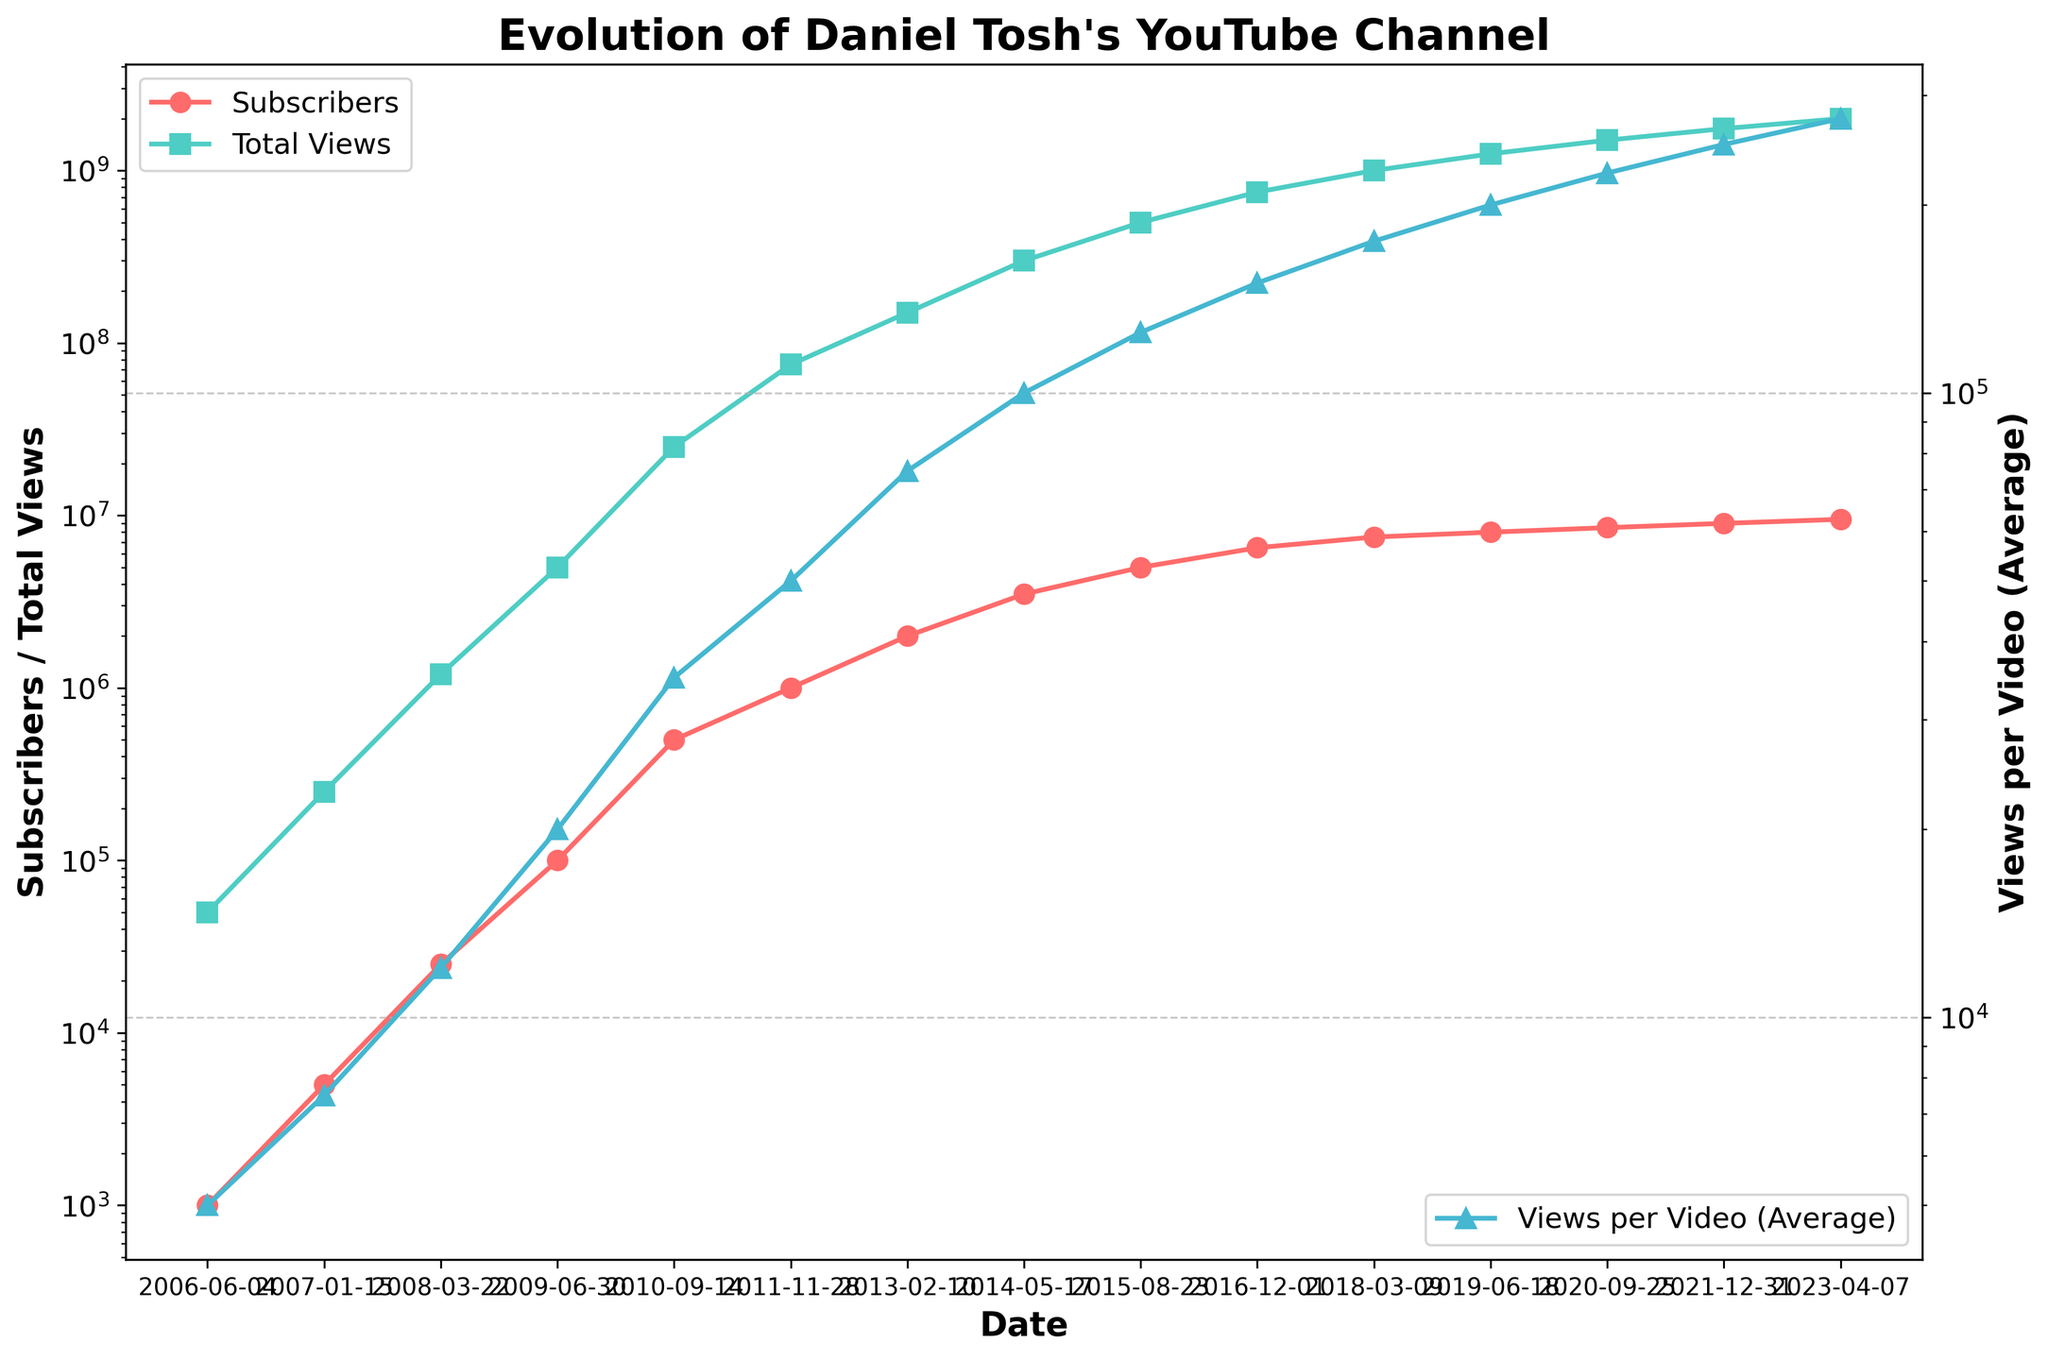What is the total number of subscribers by the end of 2021? Look at the subscriber count for the date "2021-12-31." The value given is 9,000,000.
Answer: 9,000,000 Which year saw the highest increase in subscribers? Find the differences in subscriber count between each consecutive year and compare the increases. The largest increase is between "2010-09-14" (500,000 subscribers) and "2011-11-28" (1,000,000 subscribers), showing an increase of 500,000 within approximately a year.
Answer: 2011 How does the rate of increase in subscribers compare to the rate of increase in total views over the entire period? Calculate the overall increase in subscribers from 1,000 (2006-06-04) to 9,500,000 (2023-04-07) and compare it to the total view increase from 50,000 to 2,000,000,000 in the same period. Subscribers increased by 9,499,000, while views increased by 1,999,950,000. Though both grew substantially, views had a much higher absolute increase.
Answer: Views increased more rapidly What year did views per video (average) surpass 100,000? Observe the "Views per Video (Average)" line and identify the first date after which the value exceeds 100,000. The date is "2014-05-17" with a count of 100,000.
Answer: 2014 In which period (stated in years) did Daniel Tosh's channel have a constant subscriber growth without any drop-off? Analyze the subscriber trend and identify periods where every subsequent data point shows an increase without any dips. From "2006-06-04" (1,000) to "2023-04-07" (9,500,000), the subscriber count has consistently increased.
Answer: 2006 to 2023 What is the difference in total views between 2009 and 2010? Note the values for total views on "2009-06-30" (5,000,000) and "2010-09-14" (25,000,000), then subtract the earlier value from the later one. 25,000,000 - 5,000,000 equals 20,000,000.
Answer: 20,000,000 Which color represents the average views per video on the plot? Identify the color used for the "Views per Video (Average)" line. The color utilized is blue.
Answer: Blue Did the views per video (average) reach 150,000 before or after the channel had 5 million subscribers? Check when the "Views per Video (Average)" reached 150,000 and compare it with the subscriber count timeline. It reached 150,000 on "2016-12-01," after the channel had 5 million subscribers on "2015-08-23."
Answer: After How many total views did Daniel Tosh's channel gain between 2011 and 2013? Examine the total views for "2011-11-28" (75,000,000) and "2013-02-10" (150,000,000) and find the difference. 150,000,000 - 75,000,000 equals 75,000,000.
Answer: 75,000,000 